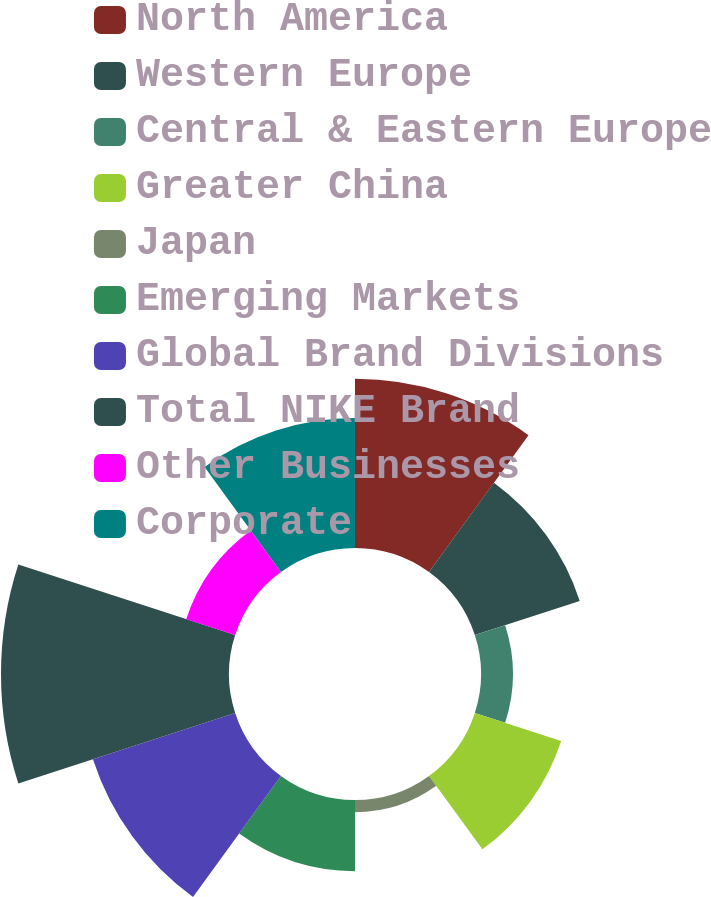Convert chart. <chart><loc_0><loc_0><loc_500><loc_500><pie_chart><fcel>North America<fcel>Western Europe<fcel>Central & Eastern Europe<fcel>Greater China<fcel>Japan<fcel>Emerging Markets<fcel>Global Brand Divisions<fcel>Total NIKE Brand<fcel>Other Businesses<fcel>Corporate<nl><fcel>16.2%<fcel>10.56%<fcel>3.05%<fcel>8.69%<fcel>1.17%<fcel>6.81%<fcel>14.32%<fcel>21.83%<fcel>4.93%<fcel>12.44%<nl></chart> 